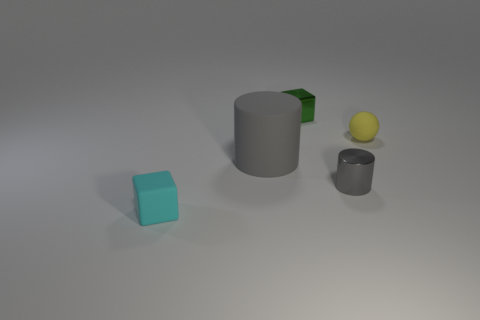Do the ball and the small cylinder have the same material?
Offer a terse response. No. How many metal cylinders are in front of the small matte thing on the right side of the small shiny thing that is behind the large thing?
Make the answer very short. 1. The tiny matte object right of the small cyan block is what color?
Your response must be concise. Yellow. The rubber object left of the gray thing that is to the left of the small green metallic object is what shape?
Provide a succinct answer. Cube. Do the big object and the metal cube have the same color?
Offer a terse response. No. How many spheres are gray metallic things or tiny cyan objects?
Provide a succinct answer. 0. There is a object that is both in front of the large gray rubber cylinder and on the left side of the tiny green object; what is it made of?
Provide a short and direct response. Rubber. What number of gray matte cylinders are behind the cyan thing?
Provide a succinct answer. 1. Do the cube in front of the tiny green metal cube and the object that is behind the matte ball have the same material?
Ensure brevity in your answer.  No. What number of objects are matte things that are right of the cyan cube or blue rubber things?
Make the answer very short. 2. 